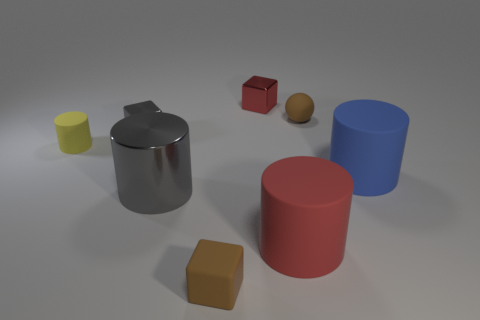Can you describe the objects arranged on the floor? Certainly. The image shows a collection of geometric figures and everyday objects placed haphazardly on a flat surface. Starting from the left, there is a small yellow cylinder, a silver kettle with a reflective surface, a small red cube, a brown sphere, a large red cylinder, and a large blue cylinder. Do the objects have any shadows, and if so, what can this tell us about the lighting? Yes, each object casts a soft shadow on the surface, indicating that there's a single light source, possibly located above and to the left of the scene. The shadows help to give depth to the objects and enhance the sense of three-dimensionality in the image. 